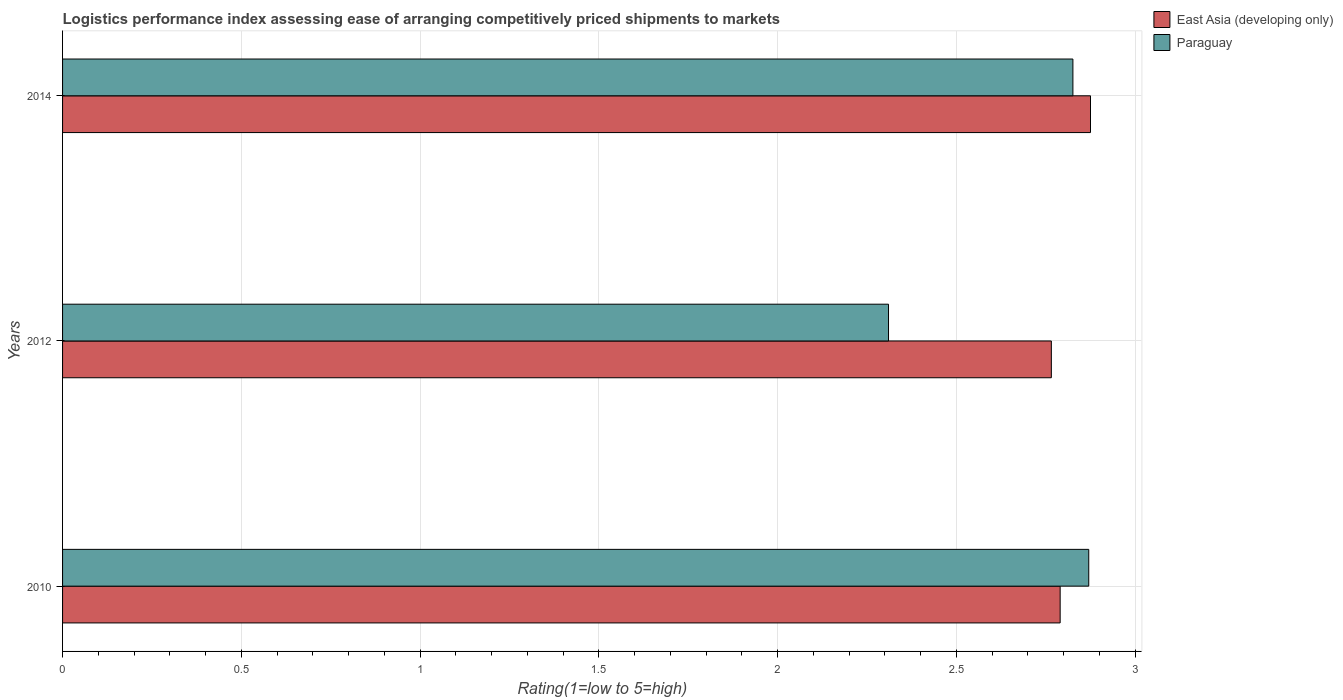How many bars are there on the 2nd tick from the bottom?
Keep it short and to the point. 2. In how many cases, is the number of bars for a given year not equal to the number of legend labels?
Ensure brevity in your answer.  0. What is the Logistic performance index in Paraguay in 2014?
Make the answer very short. 2.83. Across all years, what is the maximum Logistic performance index in Paraguay?
Provide a short and direct response. 2.87. Across all years, what is the minimum Logistic performance index in Paraguay?
Your answer should be compact. 2.31. What is the total Logistic performance index in Paraguay in the graph?
Your answer should be very brief. 8.01. What is the difference between the Logistic performance index in Paraguay in 2012 and that in 2014?
Provide a succinct answer. -0.52. What is the difference between the Logistic performance index in East Asia (developing only) in 2010 and the Logistic performance index in Paraguay in 2012?
Give a very brief answer. 0.48. What is the average Logistic performance index in Paraguay per year?
Ensure brevity in your answer.  2.67. In the year 2010, what is the difference between the Logistic performance index in East Asia (developing only) and Logistic performance index in Paraguay?
Your answer should be compact. -0.08. In how many years, is the Logistic performance index in Paraguay greater than 2.5 ?
Offer a terse response. 2. What is the ratio of the Logistic performance index in East Asia (developing only) in 2010 to that in 2012?
Your answer should be compact. 1.01. What is the difference between the highest and the second highest Logistic performance index in Paraguay?
Provide a succinct answer. 0.04. What is the difference between the highest and the lowest Logistic performance index in East Asia (developing only)?
Make the answer very short. 0.11. In how many years, is the Logistic performance index in East Asia (developing only) greater than the average Logistic performance index in East Asia (developing only) taken over all years?
Your response must be concise. 1. Is the sum of the Logistic performance index in East Asia (developing only) in 2010 and 2014 greater than the maximum Logistic performance index in Paraguay across all years?
Your answer should be very brief. Yes. What does the 2nd bar from the top in 2010 represents?
Ensure brevity in your answer.  East Asia (developing only). What does the 1st bar from the bottom in 2012 represents?
Keep it short and to the point. East Asia (developing only). Are all the bars in the graph horizontal?
Give a very brief answer. Yes. How many years are there in the graph?
Ensure brevity in your answer.  3. What is the difference between two consecutive major ticks on the X-axis?
Provide a succinct answer. 0.5. Are the values on the major ticks of X-axis written in scientific E-notation?
Give a very brief answer. No. Where does the legend appear in the graph?
Your answer should be very brief. Top right. How are the legend labels stacked?
Ensure brevity in your answer.  Vertical. What is the title of the graph?
Your answer should be very brief. Logistics performance index assessing ease of arranging competitively priced shipments to markets. Does "High income: nonOECD" appear as one of the legend labels in the graph?
Ensure brevity in your answer.  No. What is the label or title of the X-axis?
Ensure brevity in your answer.  Rating(1=low to 5=high). What is the label or title of the Y-axis?
Your answer should be compact. Years. What is the Rating(1=low to 5=high) of East Asia (developing only) in 2010?
Your response must be concise. 2.79. What is the Rating(1=low to 5=high) of Paraguay in 2010?
Ensure brevity in your answer.  2.87. What is the Rating(1=low to 5=high) of East Asia (developing only) in 2012?
Offer a very short reply. 2.77. What is the Rating(1=low to 5=high) of Paraguay in 2012?
Give a very brief answer. 2.31. What is the Rating(1=low to 5=high) in East Asia (developing only) in 2014?
Give a very brief answer. 2.87. What is the Rating(1=low to 5=high) of Paraguay in 2014?
Your response must be concise. 2.83. Across all years, what is the maximum Rating(1=low to 5=high) of East Asia (developing only)?
Offer a terse response. 2.87. Across all years, what is the maximum Rating(1=low to 5=high) of Paraguay?
Provide a succinct answer. 2.87. Across all years, what is the minimum Rating(1=low to 5=high) of East Asia (developing only)?
Your answer should be very brief. 2.77. Across all years, what is the minimum Rating(1=low to 5=high) in Paraguay?
Give a very brief answer. 2.31. What is the total Rating(1=low to 5=high) in East Asia (developing only) in the graph?
Offer a terse response. 8.43. What is the total Rating(1=low to 5=high) in Paraguay in the graph?
Provide a short and direct response. 8.01. What is the difference between the Rating(1=low to 5=high) in East Asia (developing only) in 2010 and that in 2012?
Keep it short and to the point. 0.02. What is the difference between the Rating(1=low to 5=high) of Paraguay in 2010 and that in 2012?
Keep it short and to the point. 0.56. What is the difference between the Rating(1=low to 5=high) of East Asia (developing only) in 2010 and that in 2014?
Give a very brief answer. -0.08. What is the difference between the Rating(1=low to 5=high) of Paraguay in 2010 and that in 2014?
Provide a succinct answer. 0.04. What is the difference between the Rating(1=low to 5=high) of East Asia (developing only) in 2012 and that in 2014?
Provide a succinct answer. -0.11. What is the difference between the Rating(1=low to 5=high) of Paraguay in 2012 and that in 2014?
Your response must be concise. -0.52. What is the difference between the Rating(1=low to 5=high) in East Asia (developing only) in 2010 and the Rating(1=low to 5=high) in Paraguay in 2012?
Offer a very short reply. 0.48. What is the difference between the Rating(1=low to 5=high) in East Asia (developing only) in 2010 and the Rating(1=low to 5=high) in Paraguay in 2014?
Provide a succinct answer. -0.04. What is the difference between the Rating(1=low to 5=high) in East Asia (developing only) in 2012 and the Rating(1=low to 5=high) in Paraguay in 2014?
Offer a terse response. -0.06. What is the average Rating(1=low to 5=high) of East Asia (developing only) per year?
Your response must be concise. 2.81. What is the average Rating(1=low to 5=high) in Paraguay per year?
Your response must be concise. 2.67. In the year 2010, what is the difference between the Rating(1=low to 5=high) of East Asia (developing only) and Rating(1=low to 5=high) of Paraguay?
Your response must be concise. -0.08. In the year 2012, what is the difference between the Rating(1=low to 5=high) in East Asia (developing only) and Rating(1=low to 5=high) in Paraguay?
Keep it short and to the point. 0.46. In the year 2014, what is the difference between the Rating(1=low to 5=high) of East Asia (developing only) and Rating(1=low to 5=high) of Paraguay?
Your answer should be very brief. 0.05. What is the ratio of the Rating(1=low to 5=high) in East Asia (developing only) in 2010 to that in 2012?
Provide a succinct answer. 1.01. What is the ratio of the Rating(1=low to 5=high) of Paraguay in 2010 to that in 2012?
Keep it short and to the point. 1.24. What is the ratio of the Rating(1=low to 5=high) in East Asia (developing only) in 2010 to that in 2014?
Keep it short and to the point. 0.97. What is the ratio of the Rating(1=low to 5=high) in Paraguay in 2010 to that in 2014?
Provide a short and direct response. 1.02. What is the ratio of the Rating(1=low to 5=high) in East Asia (developing only) in 2012 to that in 2014?
Provide a short and direct response. 0.96. What is the ratio of the Rating(1=low to 5=high) in Paraguay in 2012 to that in 2014?
Provide a succinct answer. 0.82. What is the difference between the highest and the second highest Rating(1=low to 5=high) in East Asia (developing only)?
Your answer should be very brief. 0.08. What is the difference between the highest and the second highest Rating(1=low to 5=high) in Paraguay?
Keep it short and to the point. 0.04. What is the difference between the highest and the lowest Rating(1=low to 5=high) in East Asia (developing only)?
Your answer should be very brief. 0.11. What is the difference between the highest and the lowest Rating(1=low to 5=high) in Paraguay?
Give a very brief answer. 0.56. 